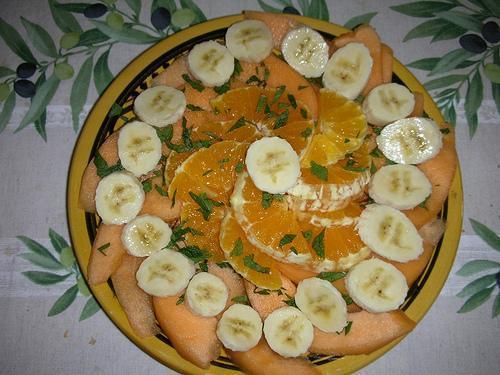How many dining tables can you see?
Give a very brief answer. 1. How many bananas are there?
Give a very brief answer. 2. 